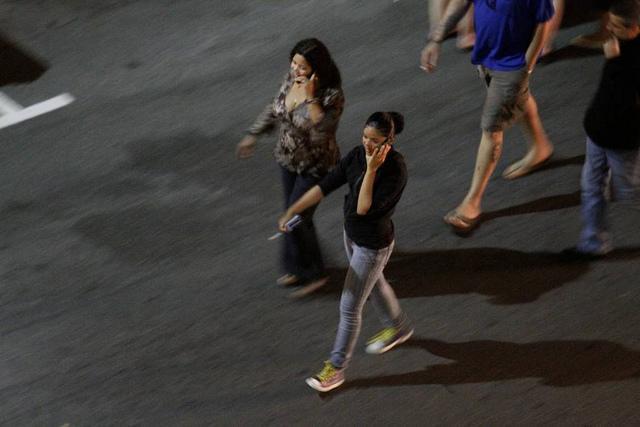How many people in the photo?
Give a very brief answer. 4. How many people are in the photo?
Give a very brief answer. 4. 